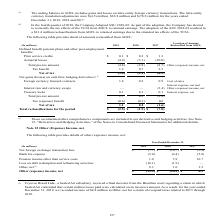According to Sealed Air Corporation's financial document, What does the table represent? detail of amounts reclassified from AOCL. The document states: "The following table provides detail of amounts reclassified from AOCL:..." Also, What years are included in the table? The document contains multiple relevant values: 2019, 2018, 2017. From the document: "(In millions) 2019 2018 2017 Location of Amount Reclassified from AOCL Defined benefit pension plans and other post-employment b (In millions) 2019 20..." Also, What is the Net of tax for 2018? According to the financial document, 0.2 (in millions). The relevant text states: "Foreign currency forward contracts 1.6 0.2 0.9 Cost of sales..." Also, can you calculate: What is the total Prior service credits for the 3 years? Based on the calculation: 0.1+0.3+1.3, the result is 1.7 (in millions). This is based on the information: "Prior service credits $ 0.1 $ 0.3 $ 1.3 Actuarial losses (4.9) (3.1) (10.0) Total pre-tax amount (4.8) (2.8) (8.7) Other (expense) in Prior service credits $ 0.1 $ 0.3 $ 1.3 Actuarial losses (4.9) (3...." The key data points involved are: 0.1, 0.3, 1.3. Also, can you calculate: What is the average Total reclassifications for the period for the 3 years? To answer this question, I need to perform calculations using the financial data. The calculation is: -(2.5+1.9+7.8)/3, which equals -4.07 (in millions). This is based on the information: "assifications for the period $ (2.5 ) $ (1.9 ) $ (7.8 ) otal reclassifications for the period $ (2.5 ) $ (1.9 ) $ (7.8 ) Total reclassifications for the period $ (2.5 ) $ (1.9 ) $ (7.8 )..." The key data points involved are: 1.9, 2.5, 7.8. Also, can you calculate: For Treasury locks in 2019, What is the Net of tax expressed as a percentage of Total pre-tax amount? Based on the calculation: 1.1/1.7, the result is 64.71 (percentage). This is based on the information: "Tax (expense) benefit (0.6) (0.1) 0.8 Net of tax 1.1 0.2 (1.6) .1 0.1 Interest expense, net Total pre-tax amount 1.7 0.3 (2.4)..." The key data points involved are: 1.1, 1.7. 